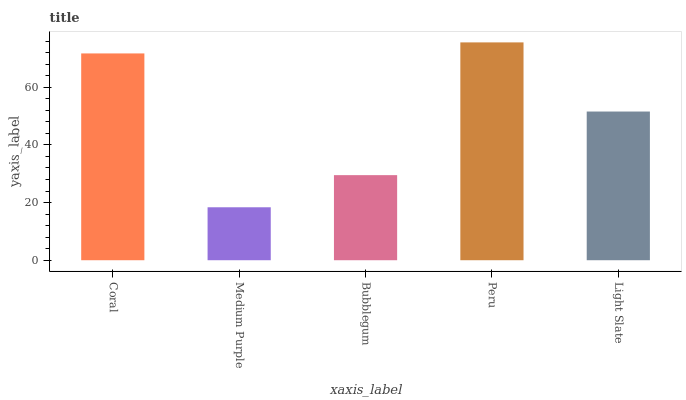Is Medium Purple the minimum?
Answer yes or no. Yes. Is Peru the maximum?
Answer yes or no. Yes. Is Bubblegum the minimum?
Answer yes or no. No. Is Bubblegum the maximum?
Answer yes or no. No. Is Bubblegum greater than Medium Purple?
Answer yes or no. Yes. Is Medium Purple less than Bubblegum?
Answer yes or no. Yes. Is Medium Purple greater than Bubblegum?
Answer yes or no. No. Is Bubblegum less than Medium Purple?
Answer yes or no. No. Is Light Slate the high median?
Answer yes or no. Yes. Is Light Slate the low median?
Answer yes or no. Yes. Is Peru the high median?
Answer yes or no. No. Is Medium Purple the low median?
Answer yes or no. No. 